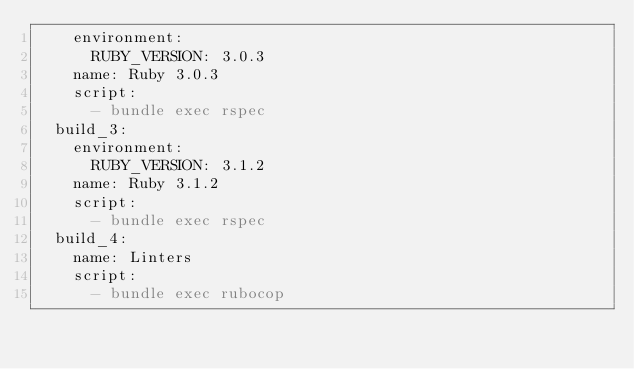Convert code to text. <code><loc_0><loc_0><loc_500><loc_500><_YAML_>    environment:
      RUBY_VERSION: 3.0.3
    name: Ruby 3.0.3
    script:
      - bundle exec rspec
  build_3:
    environment:
      RUBY_VERSION: 3.1.2
    name: Ruby 3.1.2
    script:
      - bundle exec rspec
  build_4:
    name: Linters
    script:
      - bundle exec rubocop
</code> 